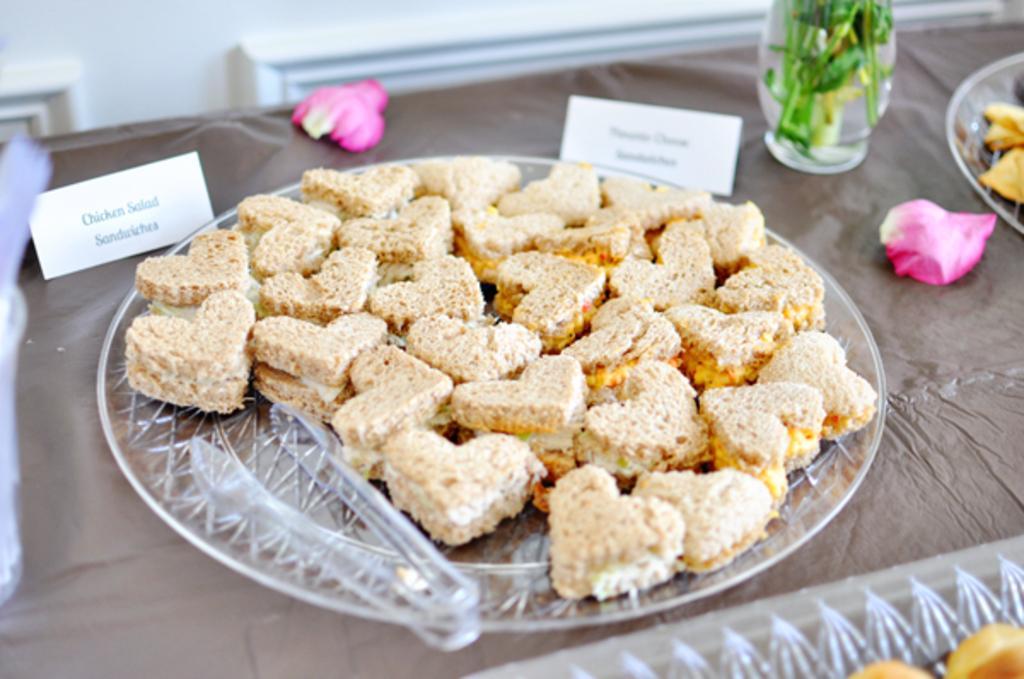Describe this image in one or two sentences. In this image we can see a table. On the table there is a plate of snacks, beside this place there is a pot and another plate and there is a nameplate and rose petals. 